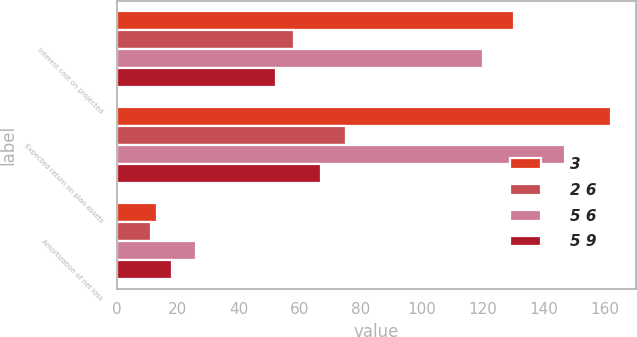<chart> <loc_0><loc_0><loc_500><loc_500><stacked_bar_chart><ecel><fcel>Interest cost on projected<fcel>Expected return on plan assets<fcel>Amortization of net loss<nl><fcel>3<fcel>130<fcel>162<fcel>13<nl><fcel>2 6<fcel>58<fcel>75<fcel>11<nl><fcel>5 6<fcel>120<fcel>147<fcel>26<nl><fcel>5 9<fcel>52<fcel>67<fcel>18<nl></chart> 